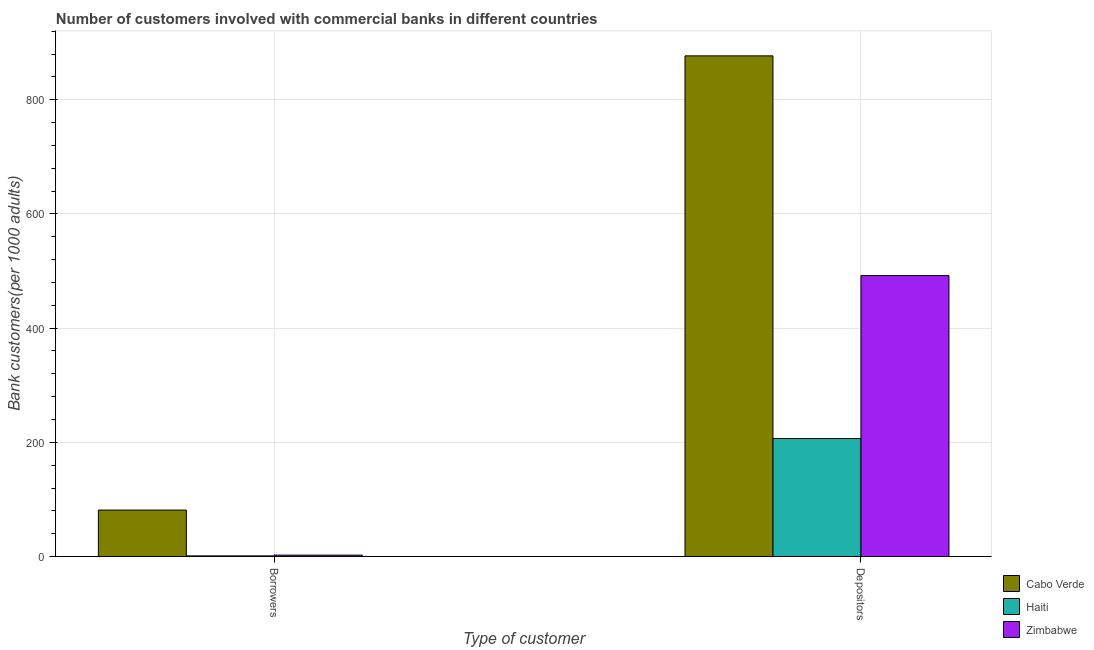Are the number of bars per tick equal to the number of legend labels?
Offer a very short reply. Yes. How many bars are there on the 2nd tick from the right?
Your response must be concise. 3. What is the label of the 1st group of bars from the left?
Your answer should be compact. Borrowers. What is the number of depositors in Cabo Verde?
Make the answer very short. 876.87. Across all countries, what is the maximum number of depositors?
Your answer should be very brief. 876.87. Across all countries, what is the minimum number of borrowers?
Offer a terse response. 1.15. In which country was the number of borrowers maximum?
Give a very brief answer. Cabo Verde. In which country was the number of depositors minimum?
Your answer should be compact. Haiti. What is the total number of depositors in the graph?
Provide a short and direct response. 1575.62. What is the difference between the number of borrowers in Cabo Verde and that in Zimbabwe?
Keep it short and to the point. 78.94. What is the difference between the number of depositors in Haiti and the number of borrowers in Cabo Verde?
Provide a succinct answer. 125.27. What is the average number of borrowers per country?
Offer a terse response. 28.34. What is the difference between the number of depositors and number of borrowers in Cabo Verde?
Give a very brief answer. 795.47. What is the ratio of the number of borrowers in Haiti to that in Cabo Verde?
Your answer should be compact. 0.01. Is the number of depositors in Zimbabwe less than that in Haiti?
Ensure brevity in your answer.  No. In how many countries, is the number of borrowers greater than the average number of borrowers taken over all countries?
Your answer should be compact. 1. What does the 1st bar from the left in Depositors represents?
Ensure brevity in your answer.  Cabo Verde. What does the 3rd bar from the right in Borrowers represents?
Provide a short and direct response. Cabo Verde. Are the values on the major ticks of Y-axis written in scientific E-notation?
Your response must be concise. No. Does the graph contain grids?
Provide a short and direct response. Yes. How many legend labels are there?
Ensure brevity in your answer.  3. How are the legend labels stacked?
Provide a succinct answer. Vertical. What is the title of the graph?
Your response must be concise. Number of customers involved with commercial banks in different countries. What is the label or title of the X-axis?
Offer a very short reply. Type of customer. What is the label or title of the Y-axis?
Provide a succinct answer. Bank customers(per 1000 adults). What is the Bank customers(per 1000 adults) in Cabo Verde in Borrowers?
Offer a very short reply. 81.4. What is the Bank customers(per 1000 adults) of Haiti in Borrowers?
Your response must be concise. 1.15. What is the Bank customers(per 1000 adults) in Zimbabwe in Borrowers?
Your response must be concise. 2.46. What is the Bank customers(per 1000 adults) of Cabo Verde in Depositors?
Provide a short and direct response. 876.87. What is the Bank customers(per 1000 adults) of Haiti in Depositors?
Keep it short and to the point. 206.67. What is the Bank customers(per 1000 adults) of Zimbabwe in Depositors?
Offer a terse response. 492.08. Across all Type of customer, what is the maximum Bank customers(per 1000 adults) of Cabo Verde?
Make the answer very short. 876.87. Across all Type of customer, what is the maximum Bank customers(per 1000 adults) of Haiti?
Offer a very short reply. 206.67. Across all Type of customer, what is the maximum Bank customers(per 1000 adults) of Zimbabwe?
Offer a very short reply. 492.08. Across all Type of customer, what is the minimum Bank customers(per 1000 adults) of Cabo Verde?
Ensure brevity in your answer.  81.4. Across all Type of customer, what is the minimum Bank customers(per 1000 adults) in Haiti?
Provide a succinct answer. 1.15. Across all Type of customer, what is the minimum Bank customers(per 1000 adults) in Zimbabwe?
Your answer should be very brief. 2.46. What is the total Bank customers(per 1000 adults) in Cabo Verde in the graph?
Provide a short and direct response. 958.27. What is the total Bank customers(per 1000 adults) in Haiti in the graph?
Make the answer very short. 207.82. What is the total Bank customers(per 1000 adults) of Zimbabwe in the graph?
Offer a very short reply. 494.54. What is the difference between the Bank customers(per 1000 adults) of Cabo Verde in Borrowers and that in Depositors?
Your response must be concise. -795.47. What is the difference between the Bank customers(per 1000 adults) in Haiti in Borrowers and that in Depositors?
Provide a succinct answer. -205.52. What is the difference between the Bank customers(per 1000 adults) of Zimbabwe in Borrowers and that in Depositors?
Your answer should be very brief. -489.62. What is the difference between the Bank customers(per 1000 adults) in Cabo Verde in Borrowers and the Bank customers(per 1000 adults) in Haiti in Depositors?
Make the answer very short. -125.27. What is the difference between the Bank customers(per 1000 adults) in Cabo Verde in Borrowers and the Bank customers(per 1000 adults) in Zimbabwe in Depositors?
Provide a short and direct response. -410.68. What is the difference between the Bank customers(per 1000 adults) in Haiti in Borrowers and the Bank customers(per 1000 adults) in Zimbabwe in Depositors?
Your response must be concise. -490.93. What is the average Bank customers(per 1000 adults) of Cabo Verde per Type of customer?
Offer a very short reply. 479.13. What is the average Bank customers(per 1000 adults) in Haiti per Type of customer?
Keep it short and to the point. 103.91. What is the average Bank customers(per 1000 adults) of Zimbabwe per Type of customer?
Provide a short and direct response. 247.27. What is the difference between the Bank customers(per 1000 adults) in Cabo Verde and Bank customers(per 1000 adults) in Haiti in Borrowers?
Offer a very short reply. 80.25. What is the difference between the Bank customers(per 1000 adults) in Cabo Verde and Bank customers(per 1000 adults) in Zimbabwe in Borrowers?
Offer a very short reply. 78.94. What is the difference between the Bank customers(per 1000 adults) of Haiti and Bank customers(per 1000 adults) of Zimbabwe in Borrowers?
Provide a short and direct response. -1.31. What is the difference between the Bank customers(per 1000 adults) in Cabo Verde and Bank customers(per 1000 adults) in Haiti in Depositors?
Your answer should be compact. 670.2. What is the difference between the Bank customers(per 1000 adults) of Cabo Verde and Bank customers(per 1000 adults) of Zimbabwe in Depositors?
Offer a terse response. 384.79. What is the difference between the Bank customers(per 1000 adults) of Haiti and Bank customers(per 1000 adults) of Zimbabwe in Depositors?
Your response must be concise. -285.41. What is the ratio of the Bank customers(per 1000 adults) of Cabo Verde in Borrowers to that in Depositors?
Provide a succinct answer. 0.09. What is the ratio of the Bank customers(per 1000 adults) in Haiti in Borrowers to that in Depositors?
Your answer should be compact. 0.01. What is the ratio of the Bank customers(per 1000 adults) of Zimbabwe in Borrowers to that in Depositors?
Make the answer very short. 0.01. What is the difference between the highest and the second highest Bank customers(per 1000 adults) in Cabo Verde?
Offer a terse response. 795.47. What is the difference between the highest and the second highest Bank customers(per 1000 adults) of Haiti?
Keep it short and to the point. 205.52. What is the difference between the highest and the second highest Bank customers(per 1000 adults) in Zimbabwe?
Provide a short and direct response. 489.62. What is the difference between the highest and the lowest Bank customers(per 1000 adults) in Cabo Verde?
Provide a short and direct response. 795.47. What is the difference between the highest and the lowest Bank customers(per 1000 adults) in Haiti?
Your response must be concise. 205.52. What is the difference between the highest and the lowest Bank customers(per 1000 adults) in Zimbabwe?
Give a very brief answer. 489.62. 